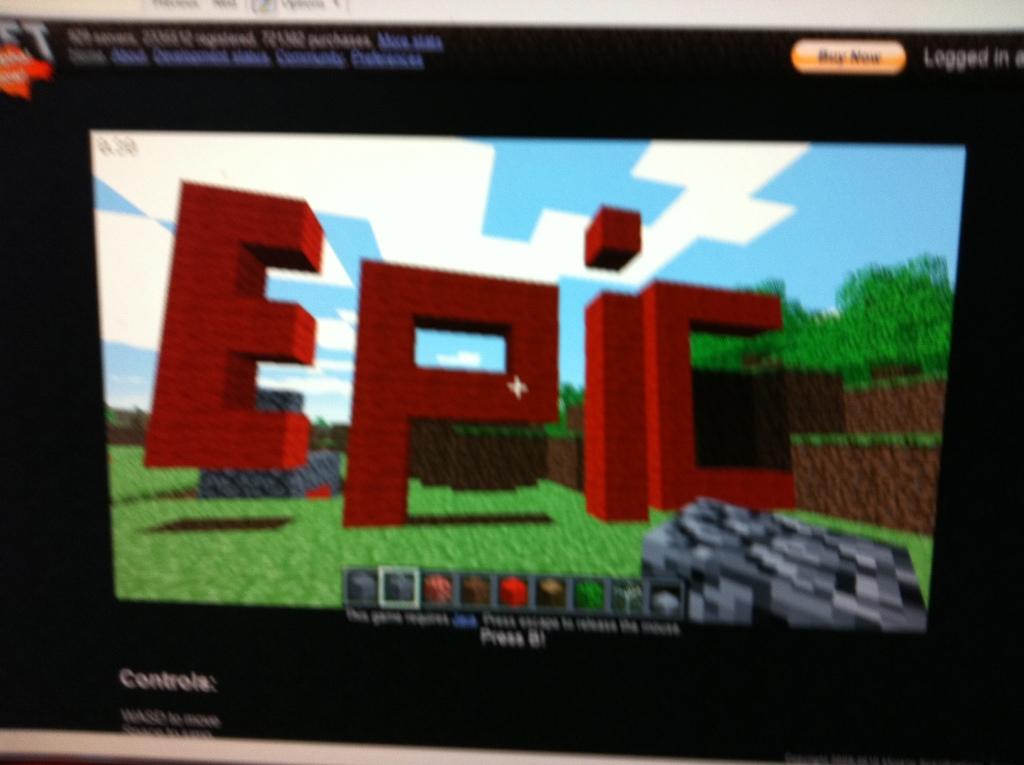What did the person spell out?
Offer a very short reply. Epic. 